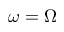Convert formula to latex. <formula><loc_0><loc_0><loc_500><loc_500>\omega = \Omega</formula> 